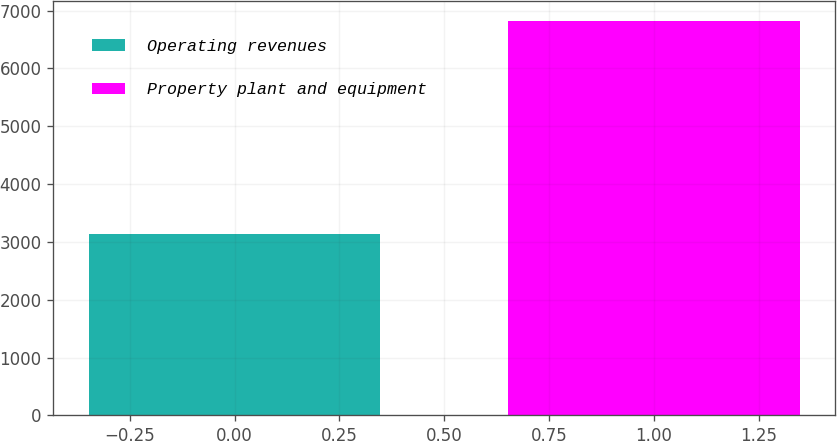<chart> <loc_0><loc_0><loc_500><loc_500><bar_chart><fcel>Operating revenues<fcel>Property plant and equipment<nl><fcel>3137<fcel>6826<nl></chart> 